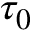Convert formula to latex. <formula><loc_0><loc_0><loc_500><loc_500>\tau _ { 0 }</formula> 